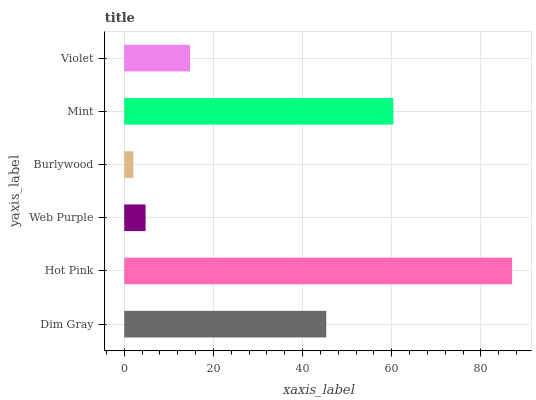Is Burlywood the minimum?
Answer yes or no. Yes. Is Hot Pink the maximum?
Answer yes or no. Yes. Is Web Purple the minimum?
Answer yes or no. No. Is Web Purple the maximum?
Answer yes or no. No. Is Hot Pink greater than Web Purple?
Answer yes or no. Yes. Is Web Purple less than Hot Pink?
Answer yes or no. Yes. Is Web Purple greater than Hot Pink?
Answer yes or no. No. Is Hot Pink less than Web Purple?
Answer yes or no. No. Is Dim Gray the high median?
Answer yes or no. Yes. Is Violet the low median?
Answer yes or no. Yes. Is Violet the high median?
Answer yes or no. No. Is Web Purple the low median?
Answer yes or no. No. 